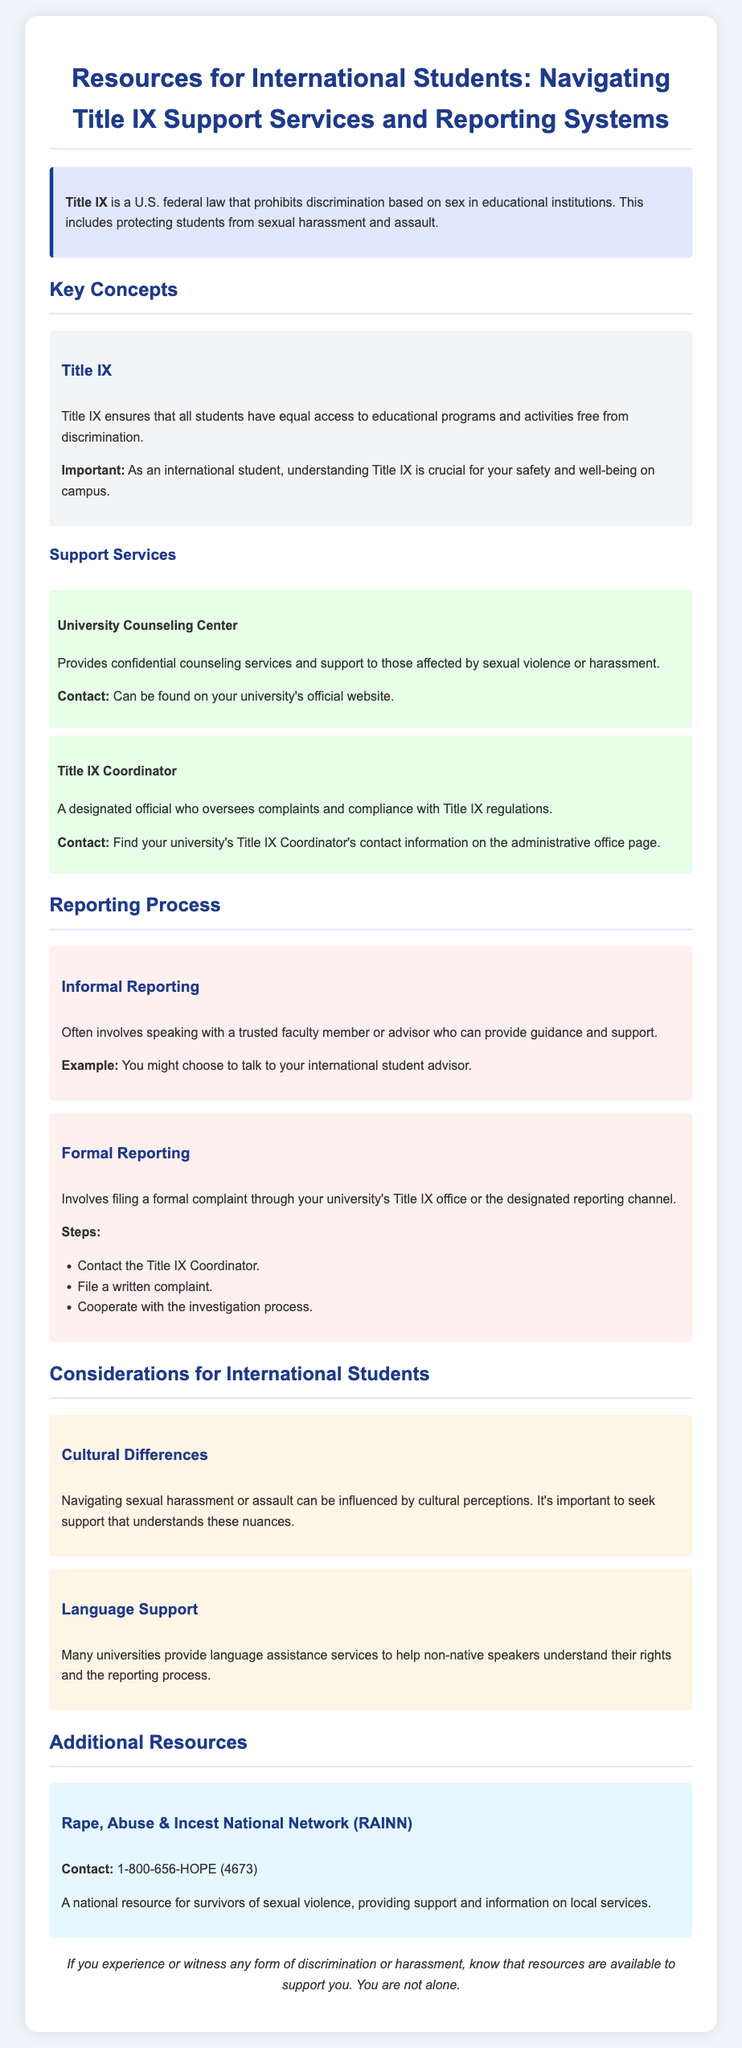What is Title IX? Title IX is a U.S. federal law that prohibits discrimination based on sex in educational institutions, protecting students from sexual harassment and assault.
Answer: U.S. federal law What does Title IX ensure? Title IX ensures that all students have equal access to educational programs and activities free from discrimination.
Answer: Equal access What is the contact for the University Counseling Center? The contact for the University Counseling Center can be found on your university's official website.
Answer: University’s official website Who is the Title IX Coordinator? The Title IX Coordinator is a designated official who oversees complaints and compliance with Title IX regulations.
Answer: Designated official What is an example of informal reporting? Informal reporting often involves speaking with a trusted faculty member or advisor for guidance and support.
Answer: Trusted faculty member What is the first step in the formal reporting process? The first step in the formal reporting process is to contact the Title IX Coordinator.
Answer: Contact the Title IX Coordinator What consideration is important regarding cultural differences? Navigating sexual harassment or assault can be influenced by cultural perceptions.
Answer: Cultural perceptions What does RAINN stand for? RAINN stands for Rape, Abuse & Incest National Network.
Answer: Rape, Abuse & Incest National Network How can international students receive language support? Many universities provide language assistance services to help non-native speakers understand their rights and the reporting process.
Answer: Language assistance services 